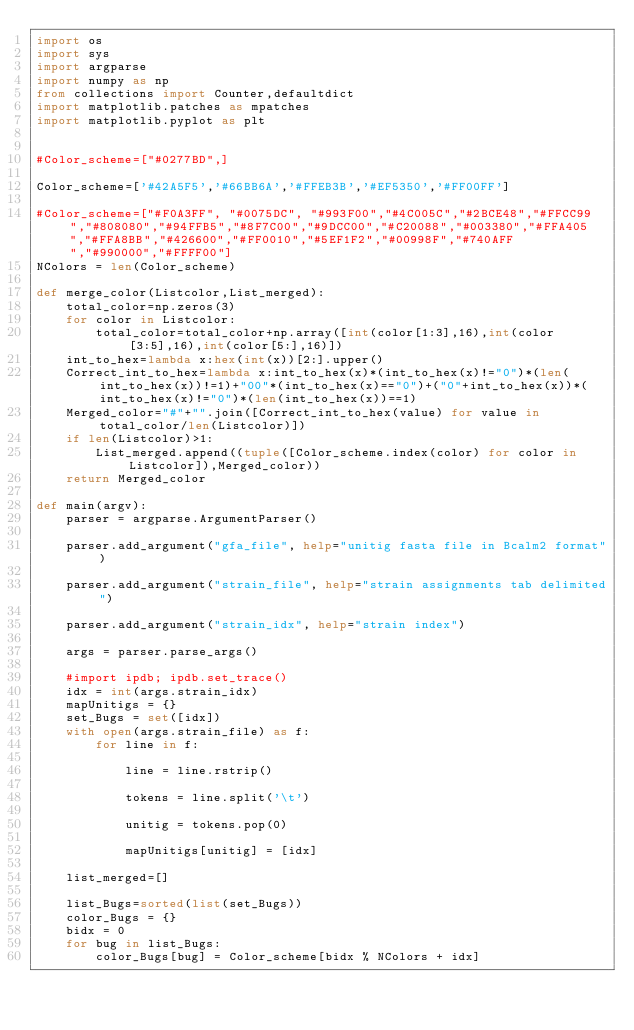Convert code to text. <code><loc_0><loc_0><loc_500><loc_500><_Python_>import os
import sys
import argparse
import numpy as np
from collections import Counter,defaultdict
import matplotlib.patches as mpatches
import matplotlib.pyplot as plt


#Color_scheme=["#0277BD",]

Color_scheme=['#42A5F5','#66BB6A','#FFEB3B','#EF5350','#FF00FF']

#Color_scheme=["#F0A3FF", "#0075DC", "#993F00","#4C005C","#2BCE48","#FFCC99","#808080","#94FFB5","#8F7C00","#9DCC00","#C20088","#003380","#FFA405","#FFA8BB","#426600","#FF0010","#5EF1F2","#00998F","#740AFF","#990000","#FFFF00"]
NColors = len(Color_scheme)

def merge_color(Listcolor,List_merged):
    total_color=np.zeros(3)
    for color in Listcolor:
        total_color=total_color+np.array([int(color[1:3],16),int(color[3:5],16),int(color[5:],16)])
    int_to_hex=lambda x:hex(int(x))[2:].upper()
    Correct_int_to_hex=lambda x:int_to_hex(x)*(int_to_hex(x)!="0")*(len(int_to_hex(x))!=1)+"00"*(int_to_hex(x)=="0")+("0"+int_to_hex(x))*(int_to_hex(x)!="0")*(len(int_to_hex(x))==1)
    Merged_color="#"+"".join([Correct_int_to_hex(value) for value in total_color/len(Listcolor)])
    if len(Listcolor)>1:
        List_merged.append((tuple([Color_scheme.index(color) for color in Listcolor]),Merged_color))
    return Merged_color
    
def main(argv):
    parser = argparse.ArgumentParser()

    parser.add_argument("gfa_file", help="unitig fasta file in Bcalm2 format")

    parser.add_argument("strain_file", help="strain assignments tab delimited")

    parser.add_argument("strain_idx", help="strain index")

    args = parser.parse_args()

    #import ipdb; ipdb.set_trace()
    idx = int(args.strain_idx)
    mapUnitigs = {}
    set_Bugs = set([idx])
    with open(args.strain_file) as f:
        for line in f:
        
            line = line.rstrip()
        
            tokens = line.split('\t')
        
            unitig = tokens.pop(0)
            
            mapUnitigs[unitig] = [idx]
    
    list_merged=[]

    list_Bugs=sorted(list(set_Bugs))
    color_Bugs = {}
    bidx = 0
    for bug in list_Bugs:
        color_Bugs[bug] = Color_scheme[bidx % NColors + idx]</code> 